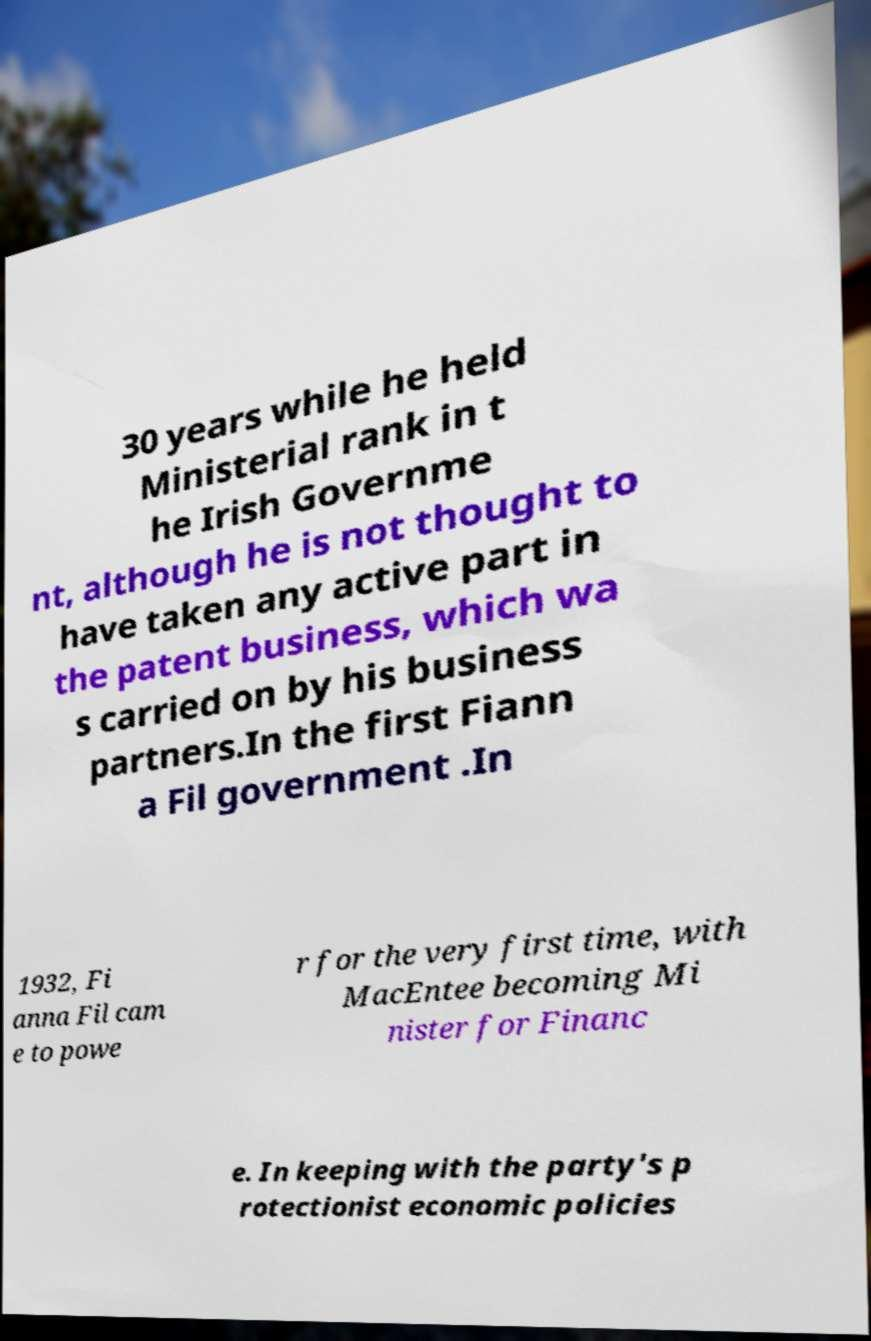Can you accurately transcribe the text from the provided image for me? 30 years while he held Ministerial rank in t he Irish Governme nt, although he is not thought to have taken any active part in the patent business, which wa s carried on by his business partners.In the first Fiann a Fil government .In 1932, Fi anna Fil cam e to powe r for the very first time, with MacEntee becoming Mi nister for Financ e. In keeping with the party's p rotectionist economic policies 